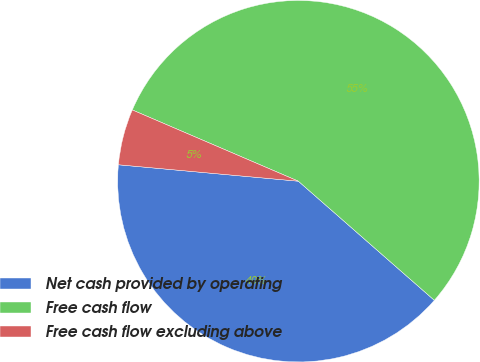<chart> <loc_0><loc_0><loc_500><loc_500><pie_chart><fcel>Net cash provided by operating<fcel>Free cash flow<fcel>Free cash flow excluding above<nl><fcel>40.0%<fcel>55.0%<fcel>5.0%<nl></chart> 